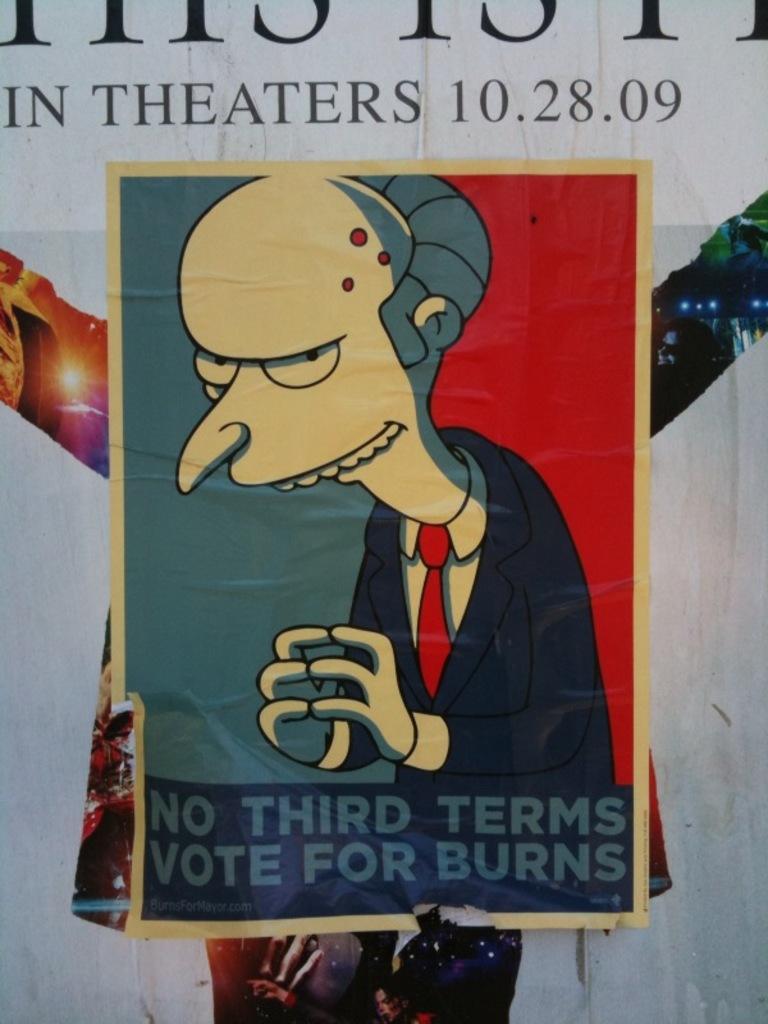How would you summarize this image in a sentence or two? In the image there is a anime poster on the wall with text on it. 